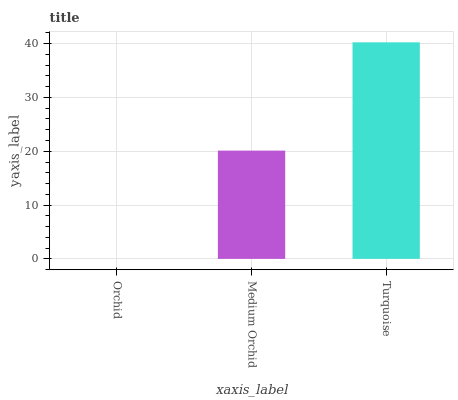Is Orchid the minimum?
Answer yes or no. Yes. Is Turquoise the maximum?
Answer yes or no. Yes. Is Medium Orchid the minimum?
Answer yes or no. No. Is Medium Orchid the maximum?
Answer yes or no. No. Is Medium Orchid greater than Orchid?
Answer yes or no. Yes. Is Orchid less than Medium Orchid?
Answer yes or no. Yes. Is Orchid greater than Medium Orchid?
Answer yes or no. No. Is Medium Orchid less than Orchid?
Answer yes or no. No. Is Medium Orchid the high median?
Answer yes or no. Yes. Is Medium Orchid the low median?
Answer yes or no. Yes. Is Turquoise the high median?
Answer yes or no. No. Is Turquoise the low median?
Answer yes or no. No. 